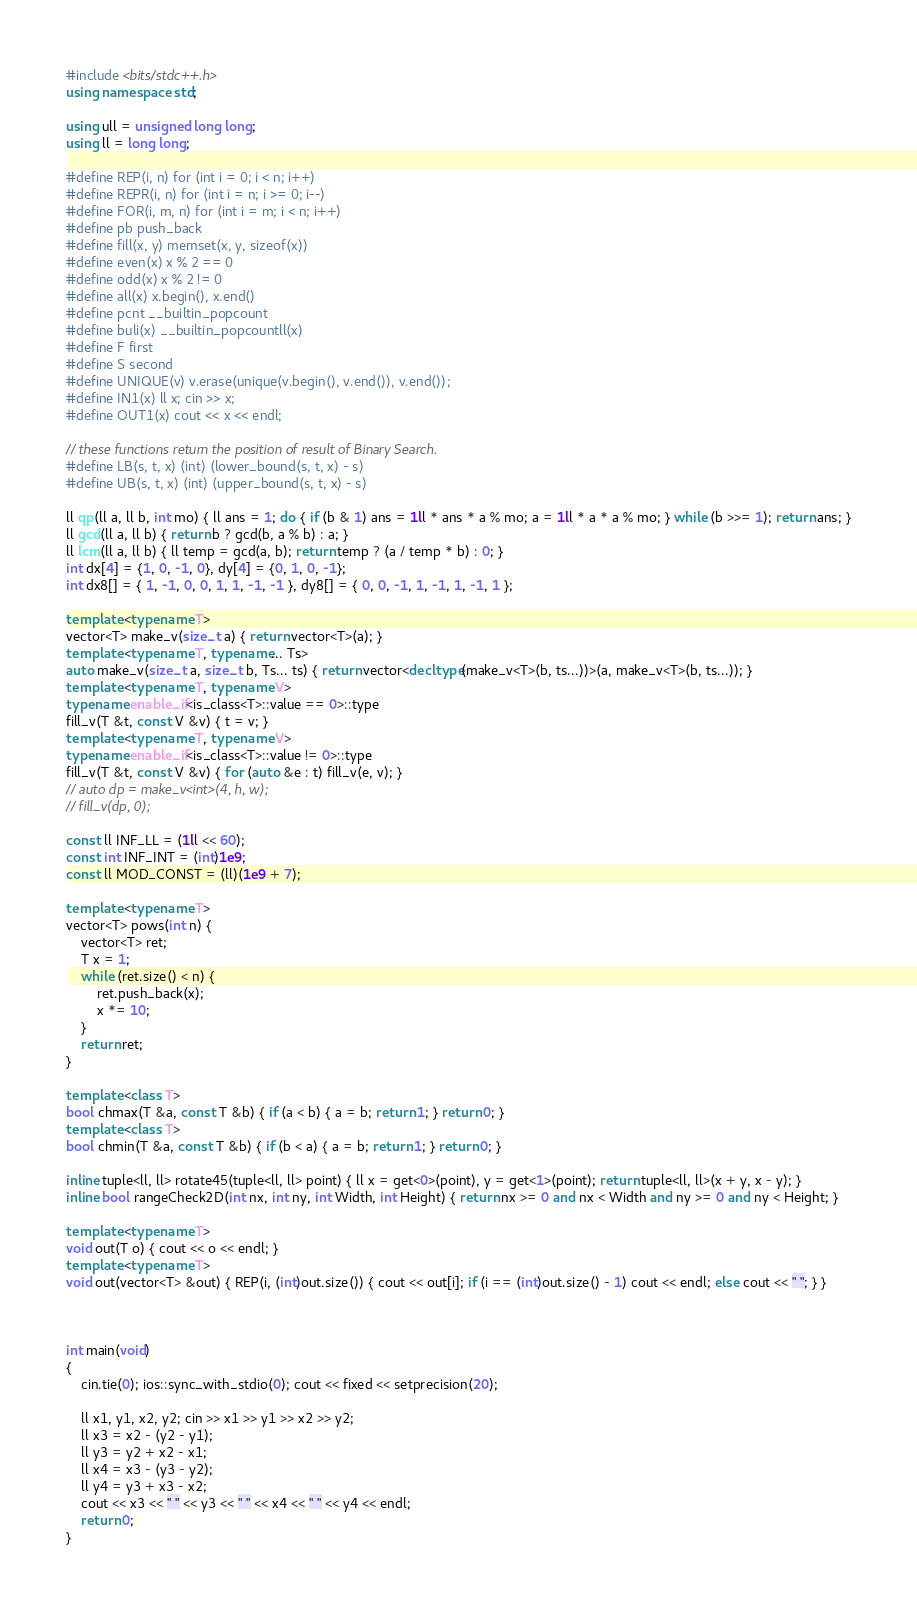<code> <loc_0><loc_0><loc_500><loc_500><_C++_>#include <bits/stdc++.h>
using namespace std;

using ull = unsigned long long;
using ll = long long;

#define REP(i, n) for (int i = 0; i < n; i++)
#define REPR(i, n) for (int i = n; i >= 0; i--)
#define FOR(i, m, n) for (int i = m; i < n; i++)
#define pb push_back
#define fill(x, y) memset(x, y, sizeof(x))
#define even(x) x % 2 == 0
#define odd(x) x % 2 != 0
#define all(x) x.begin(), x.end()
#define pcnt __builtin_popcount
#define buli(x) __builtin_popcountll(x)
#define F first
#define S second
#define UNIQUE(v) v.erase(unique(v.begin(), v.end()), v.end());
#define IN1(x) ll x; cin >> x;
#define OUT1(x) cout << x << endl;

// these functions return the position of result of Binary Search.
#define LB(s, t, x) (int) (lower_bound(s, t, x) - s)
#define UB(s, t, x) (int) (upper_bound(s, t, x) - s)

ll qp(ll a, ll b, int mo) { ll ans = 1; do { if (b & 1) ans = 1ll * ans * a % mo; a = 1ll * a * a % mo; } while (b >>= 1); return ans; }
ll gcd(ll a, ll b) { return b ? gcd(b, a % b) : a; }
ll lcm(ll a, ll b) { ll temp = gcd(a, b); return temp ? (a / temp * b) : 0; }
int dx[4] = {1, 0, -1, 0}, dy[4] = {0, 1, 0, -1};
int dx8[] = { 1, -1, 0, 0, 1, 1, -1, -1 }, dy8[] = { 0, 0, -1, 1, -1, 1, -1, 1 };

template <typename T>
vector<T> make_v(size_t a) { return vector<T>(a); }
template <typename T, typename... Ts>
auto make_v(size_t a, size_t b, Ts... ts) { return vector<decltype(make_v<T>(b, ts...))>(a, make_v<T>(b, ts...)); }
template <typename T, typename V>
typename enable_if<is_class<T>::value == 0>::type
fill_v(T &t, const V &v) { t = v; }
template <typename T, typename V>
typename enable_if<is_class<T>::value != 0>::type
fill_v(T &t, const V &v) { for (auto &e : t) fill_v(e, v); }
// auto dp = make_v<int>(4, h, w);
// fill_v(dp, 0);

const ll INF_LL = (1ll << 60);
const int INF_INT = (int)1e9;
const ll MOD_CONST = (ll)(1e9 + 7);

template <typename T>
vector<T> pows(int n) {
	vector<T> ret;
	T x = 1;
	while (ret.size() < n) {
		ret.push_back(x);
		x *= 10;
	}
	return ret;
}

template <class T>
bool chmax(T &a, const T &b) { if (a < b) { a = b; return 1; } return 0; }
template <class T>
bool chmin(T &a, const T &b) { if (b < a) { a = b; return 1; } return 0; }

inline tuple<ll, ll> rotate45(tuple<ll, ll> point) { ll x = get<0>(point), y = get<1>(point); return tuple<ll, ll>(x + y, x - y); }
inline bool rangeCheck2D(int nx, int ny, int Width, int Height) { return nx >= 0 and nx < Width and ny >= 0 and ny < Height; }

template <typename T>
void out(T o) { cout << o << endl; }
template <typename T>
void out(vector<T> &out) { REP(i, (int)out.size()) { cout << out[i]; if (i == (int)out.size() - 1) cout << endl; else cout << " "; } }



int main(void)
{
	cin.tie(0); ios::sync_with_stdio(0); cout << fixed << setprecision(20);

	ll x1, y1, x2, y2; cin >> x1 >> y1 >> x2 >> y2;
	ll x3 = x2 - (y2 - y1);
	ll y3 = y2 + x2 - x1;
	ll x4 = x3 - (y3 - y2);
	ll y4 = y3 + x3 - x2;
	cout << x3 << " " << y3 << " " << x4 << " " << y4 << endl;
	return 0;
}
</code> 